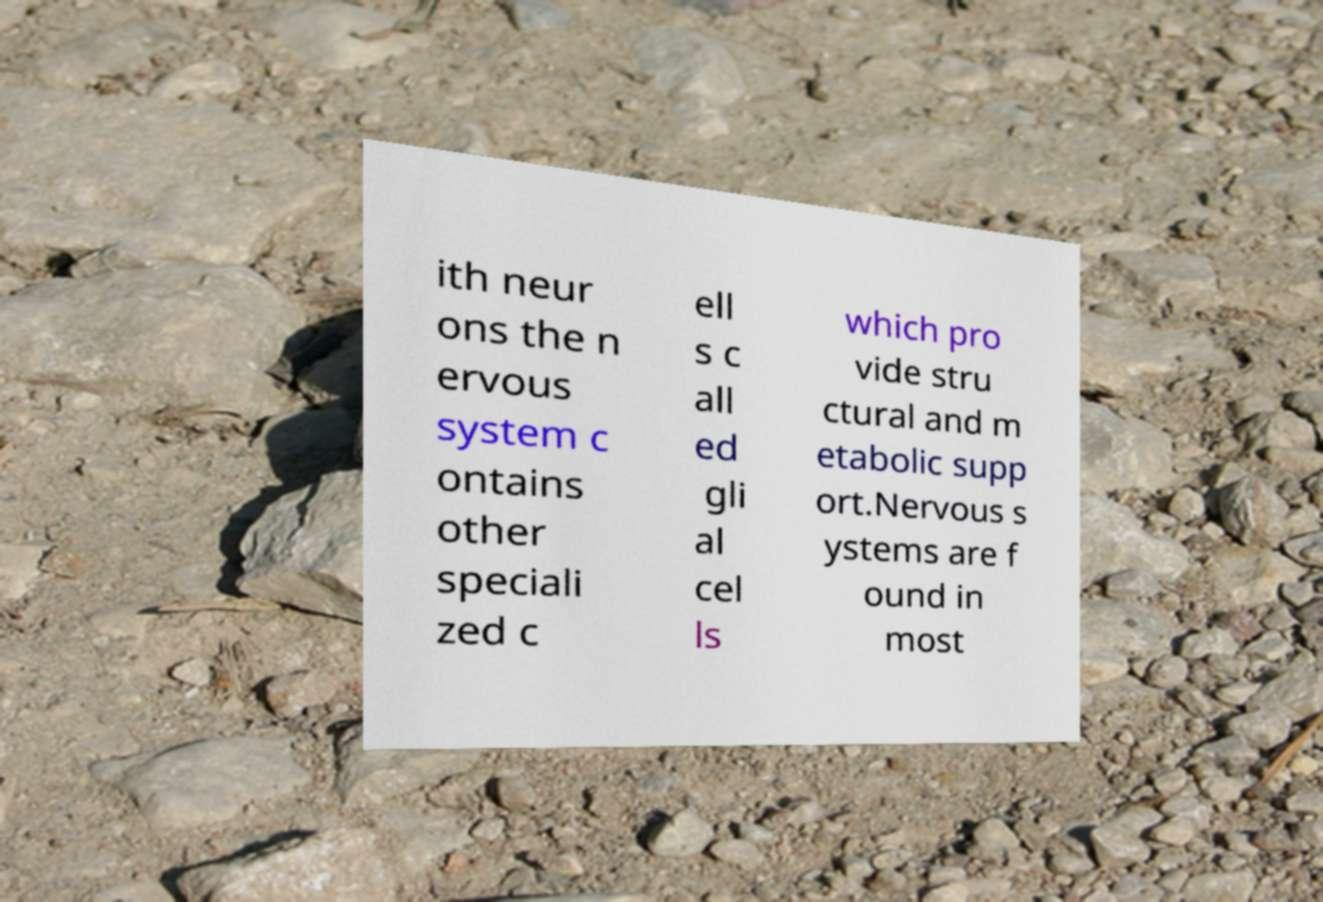Could you extract and type out the text from this image? ith neur ons the n ervous system c ontains other speciali zed c ell s c all ed gli al cel ls which pro vide stru ctural and m etabolic supp ort.Nervous s ystems are f ound in most 